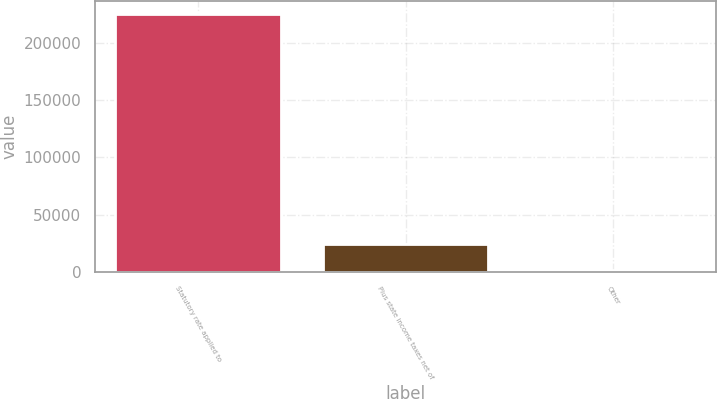<chart> <loc_0><loc_0><loc_500><loc_500><bar_chart><fcel>Statutory rate applied to<fcel>Plus state income taxes net of<fcel>Other<nl><fcel>225458<fcel>24206.3<fcel>1845<nl></chart> 